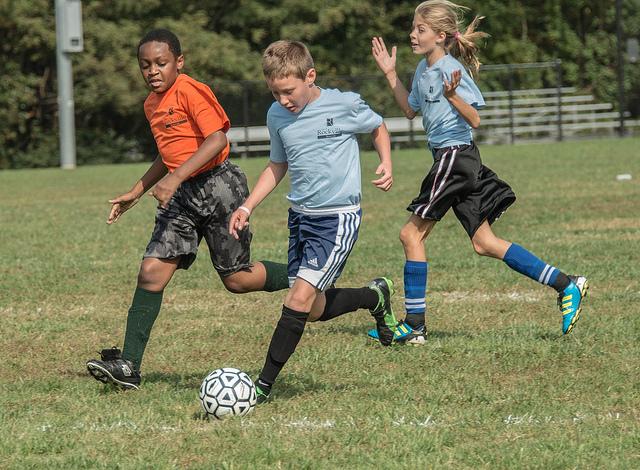Which person is closer to kicking the ball?
Answer briefly. Boy in blue. Why do the boys have different colored shirts?
Quick response, please. Different teams. What color is the child's shirt who is kicking a ball?
Short answer required. Blue. Is anyone laying down?
Write a very short answer. No. Is the female child dressed differently than the boys?
Write a very short answer. No. Is he going to pass the ball to the girl?
Concise answer only. No. Are the boys left or right footed?
Give a very brief answer. Right. How many people are in the picture?
Keep it brief. 3. How many boys are playing?
Concise answer only. 2. 